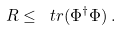<formula> <loc_0><loc_0><loc_500><loc_500>R \leq \ t r ( \Phi ^ { \dagger } \Phi ) \, .</formula> 